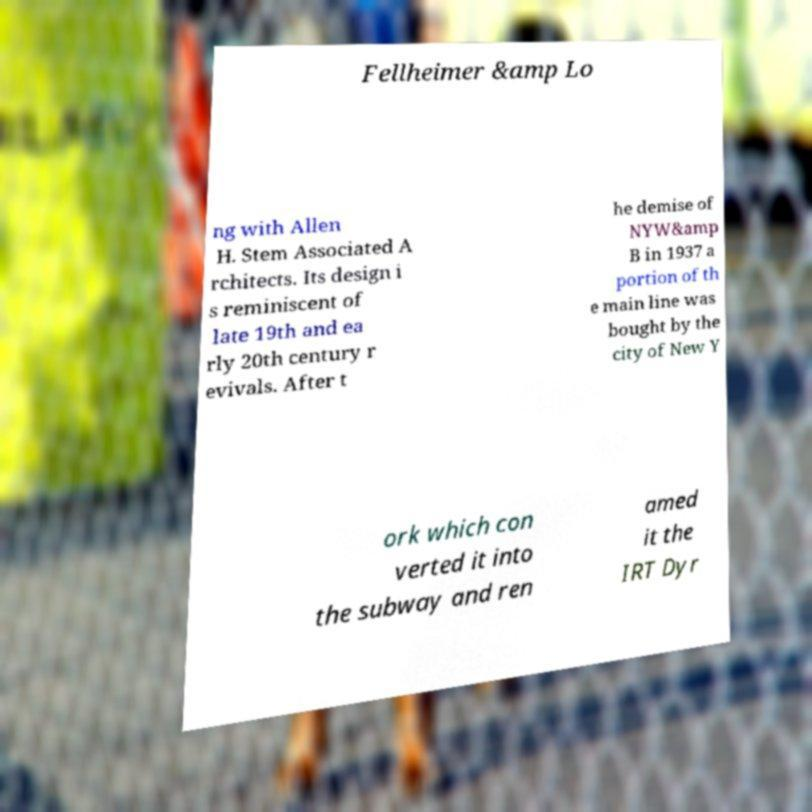Could you assist in decoding the text presented in this image and type it out clearly? Fellheimer &amp Lo ng with Allen H. Stem Associated A rchitects. Its design i s reminiscent of late 19th and ea rly 20th century r evivals. After t he demise of NYW&amp B in 1937 a portion of th e main line was bought by the city of New Y ork which con verted it into the subway and ren amed it the IRT Dyr 